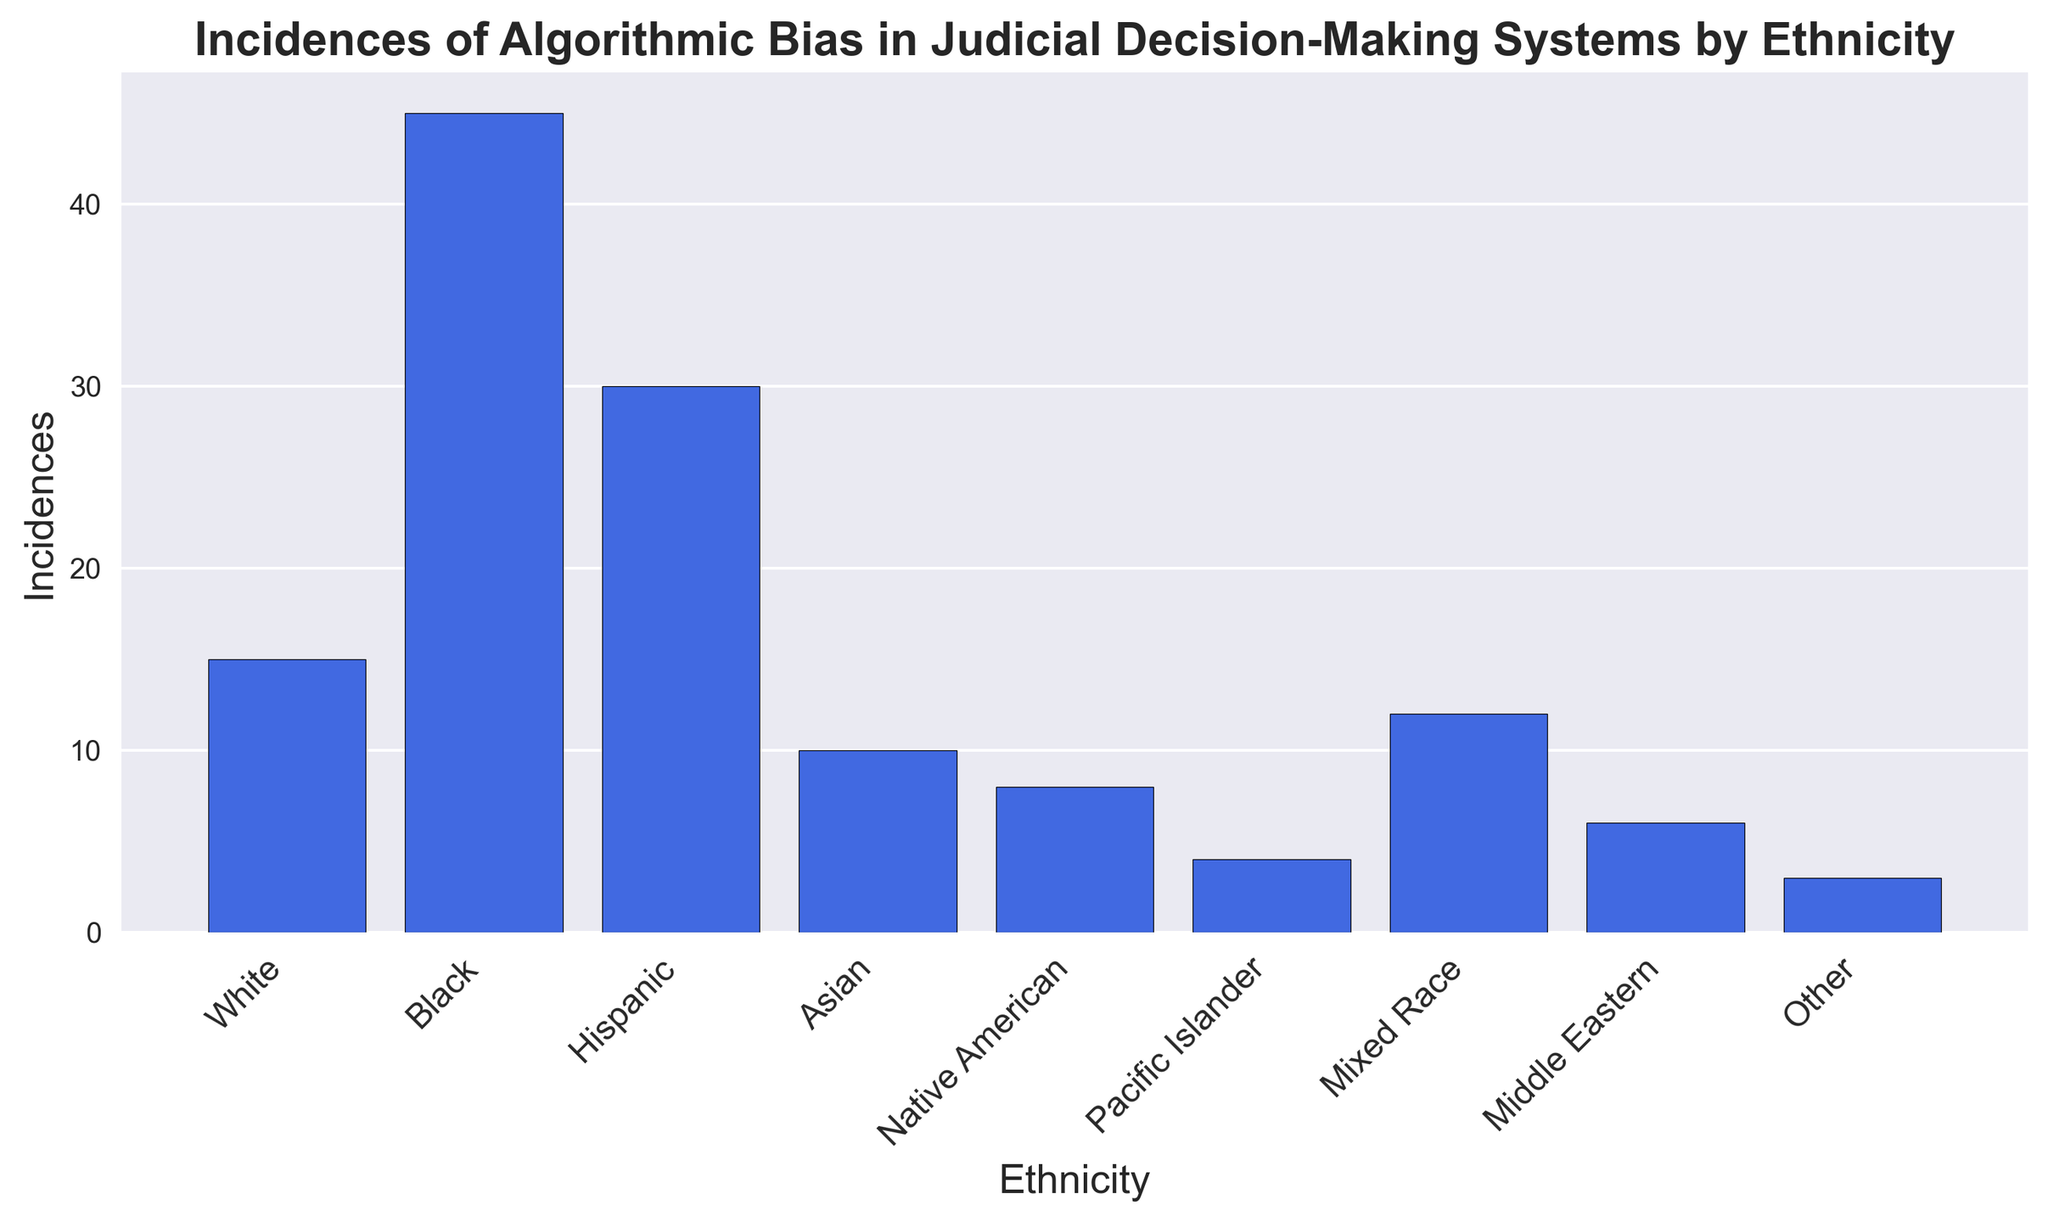What ethnicity has the highest number of incidences of algorithmic bias in judicial decision-making systems? To determine the ethnicity with the highest number of incidences, look at the bar with the greatest height. The "Black" bar is the tallest.
Answer: Black What are the total incidences of algorithmic bias for Black and Hispanic ethnicities combined? To find the total, add the incidence values for Black (45) and Hispanic (30). 45 + 30 = 75.
Answer: 75 Which ethnic group has fewer incidences of algorithmic bias: Native American or Asian? Compare the heights of the bars for Native American and Asian. Native American has 8 incidences, whereas Asian has 10 incidences. Therefore, Native American has fewer incidences.
Answer: Native American What is the average number of incidences of algorithmic bias across all ethnicities listed? Sum all the incidences and divide by the number of ethnicities. The sum is 15 + 45 + 30 + 10 + 8 + 4 + 12 + 6 + 3 = 133. There are 9 ethnicities, so the average is 133 / 9 ≈ 14.78.
Answer: 14.78 By how many incidences does the Black ethnicity exceed the White ethnicity in terms of algorithmic bias? Subtract the number of incidences for White (15) from the number of incidences for Black (45). 45 - 15 = 30.
Answer: 30 Which ethnic group has exactly half the number of incidences compared to the Hispanic ethnic group? Hispanic has 30 incidences. Half of 30 is 15, which corresponds to the White ethnic group.
Answer: White Rank the ethnicities in descending order based on the number of algorithmic bias incidences. The incidences are as follows: Black (45), Hispanic (30), White (15), Mixed Race (12), Asian (10), Native American (8), Middle Eastern (6), Pacific Islander (4), Other (3).
Answer: Black, Hispanic, White, Mixed Race, Asian, Native American, Middle Eastern, Pacific Islander, Other What is the difference in incidences between Mixed Race and Middle Eastern ethnicities? Subtract the incidences for Middle Eastern (6) from those for Mixed Race (12). 12 - 6 = 6.
Answer: 6 